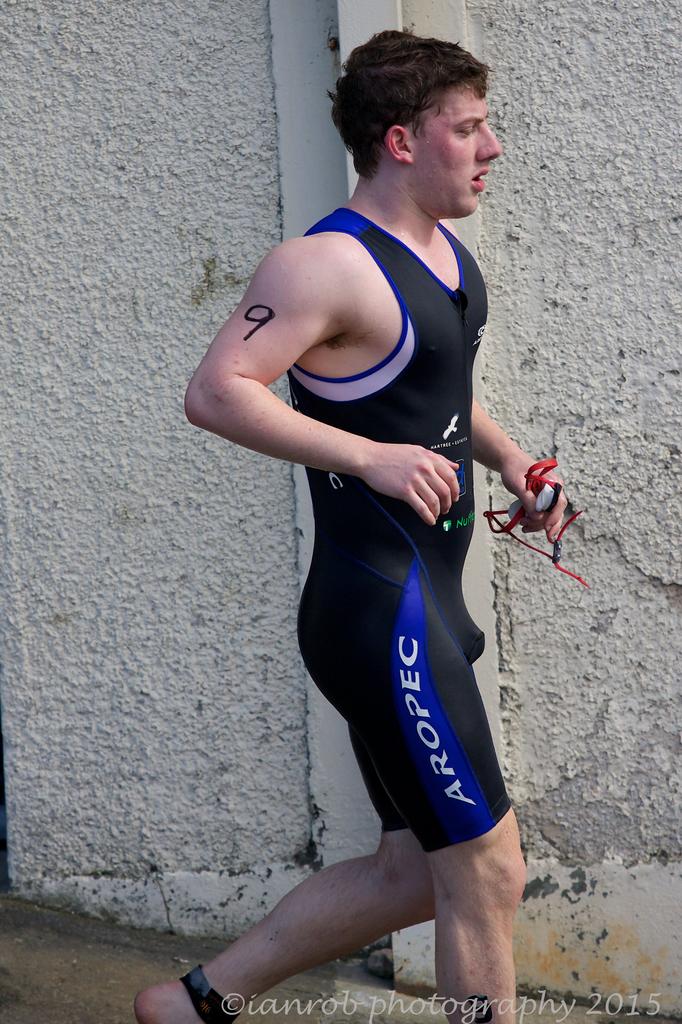What brand is that one piece?
Your response must be concise. Aropec. What number is written on the man's arm?
Provide a succinct answer. 9. 